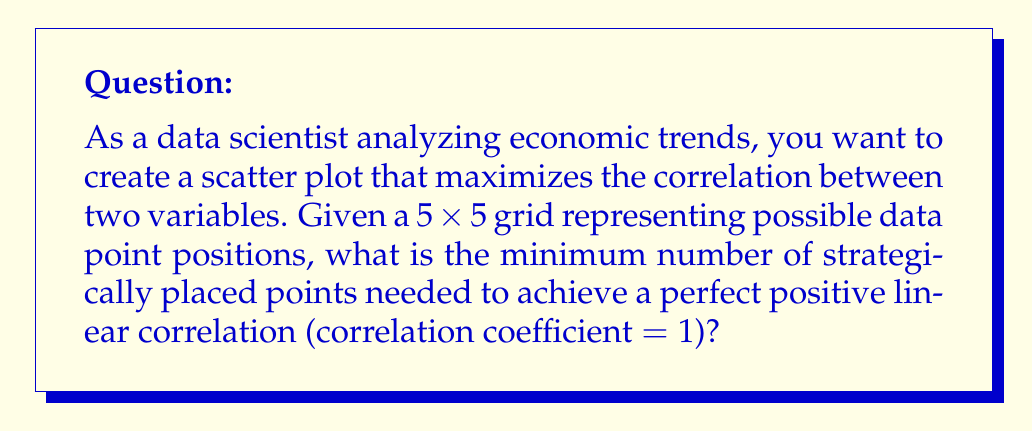Solve this math problem. To solve this problem, let's approach it step-by-step:

1. Recall that a perfect positive linear correlation (r = 1) occurs when all points fall exactly on a straight line with a positive slope.

2. In a 5x5 grid, we can achieve this by placing points along the diagonal from bottom-left to top-right.

3. The minimum number of points needed to define a straight line is 2.

4. However, in statistical analysis, it's generally preferred to have more than two data points to establish a reliable correlation. Three points are often considered the minimum for a meaningful correlation.

5. In our 5x5 grid, we can place these three points as follows:
   - (1,1): bottom-left corner
   - (3,3): center of the grid
   - (5,5): top-right corner

6. This placement gives us:
   $$y = mx + b$$
   where $m = 1$ (slope) and $b = 0$ (y-intercept)

7. We can verify that these points satisfy the equation of a straight line:
   For (1,1): $1 = 1(1) + 0$
   For (3,3): $3 = 1(3) + 0$
   For (5,5): $5 = 1(5) + 0$

8. With these three points, we have established a perfect positive linear correlation while using the minimum number of points for a statistically meaningful result.
Answer: 3 points 